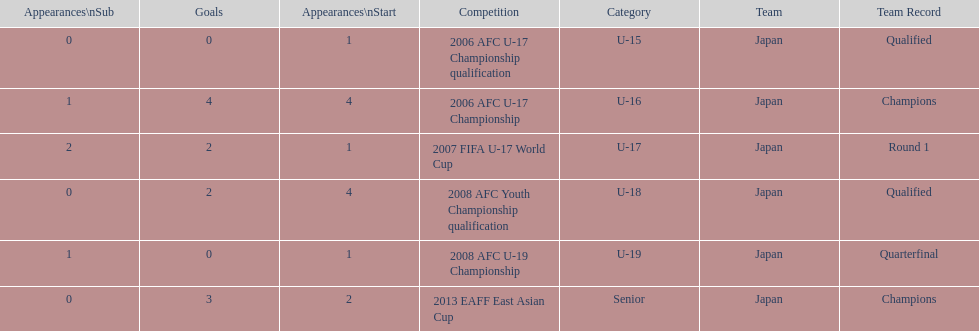Where did japan only score four goals? 2006 AFC U-17 Championship. 